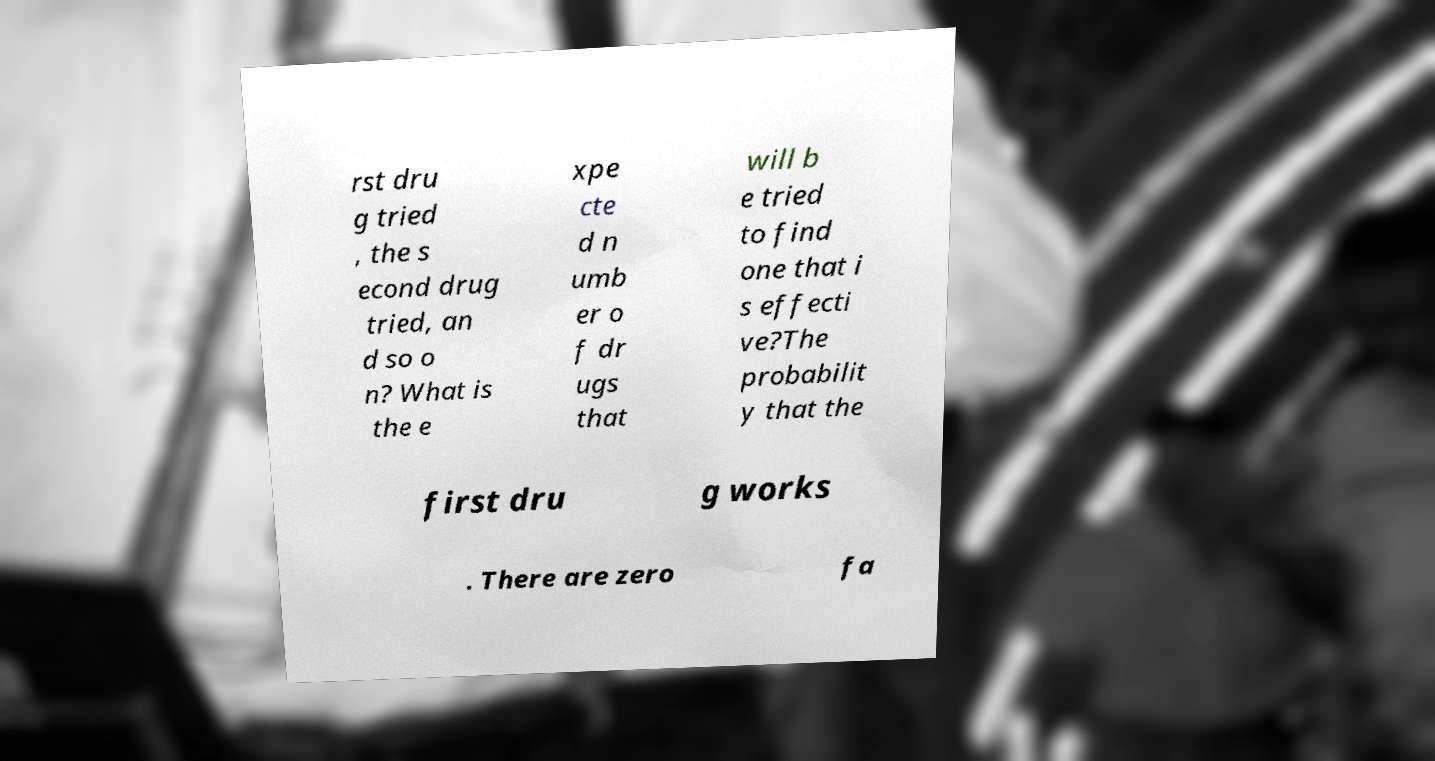I need the written content from this picture converted into text. Can you do that? rst dru g tried , the s econd drug tried, an d so o n? What is the e xpe cte d n umb er o f dr ugs that will b e tried to find one that i s effecti ve?The probabilit y that the first dru g works . There are zero fa 